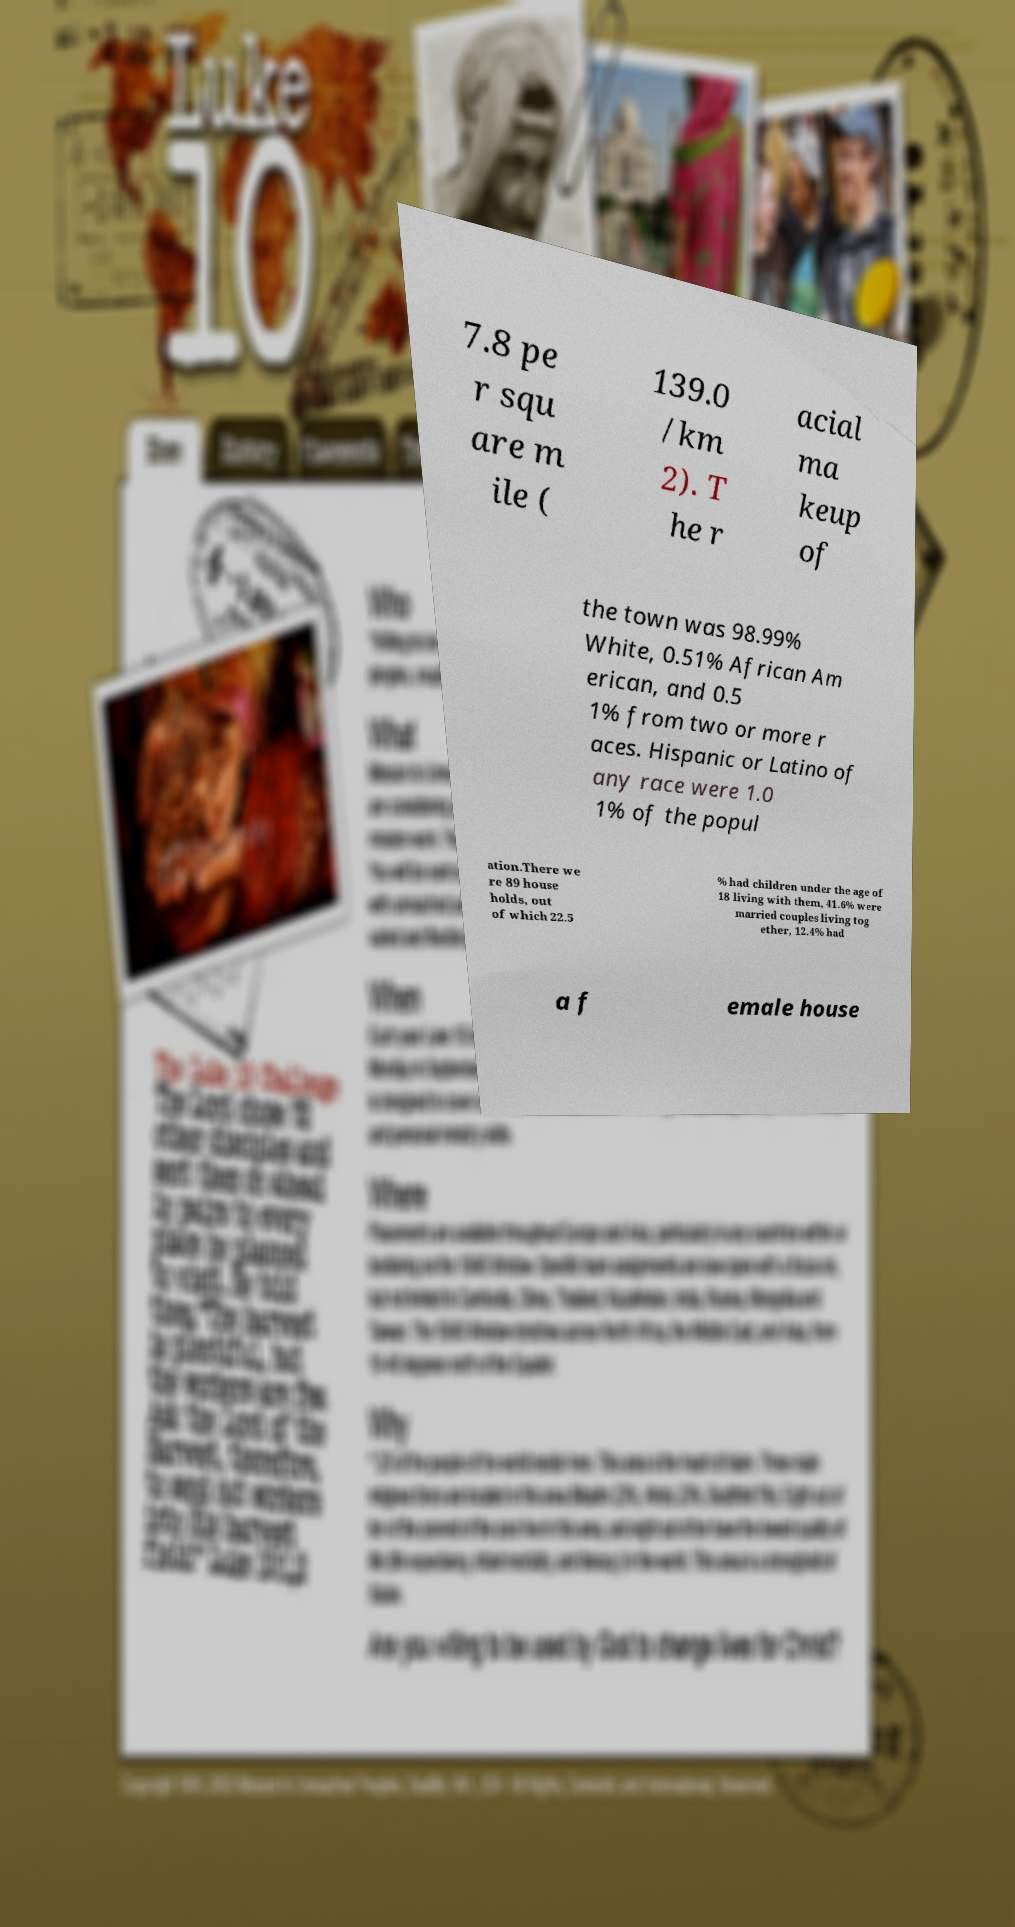There's text embedded in this image that I need extracted. Can you transcribe it verbatim? 7.8 pe r squ are m ile ( 139.0 /km 2). T he r acial ma keup of the town was 98.99% White, 0.51% African Am erican, and 0.5 1% from two or more r aces. Hispanic or Latino of any race were 1.0 1% of the popul ation.There we re 89 house holds, out of which 22.5 % had children under the age of 18 living with them, 41.6% were married couples living tog ether, 12.4% had a f emale house 